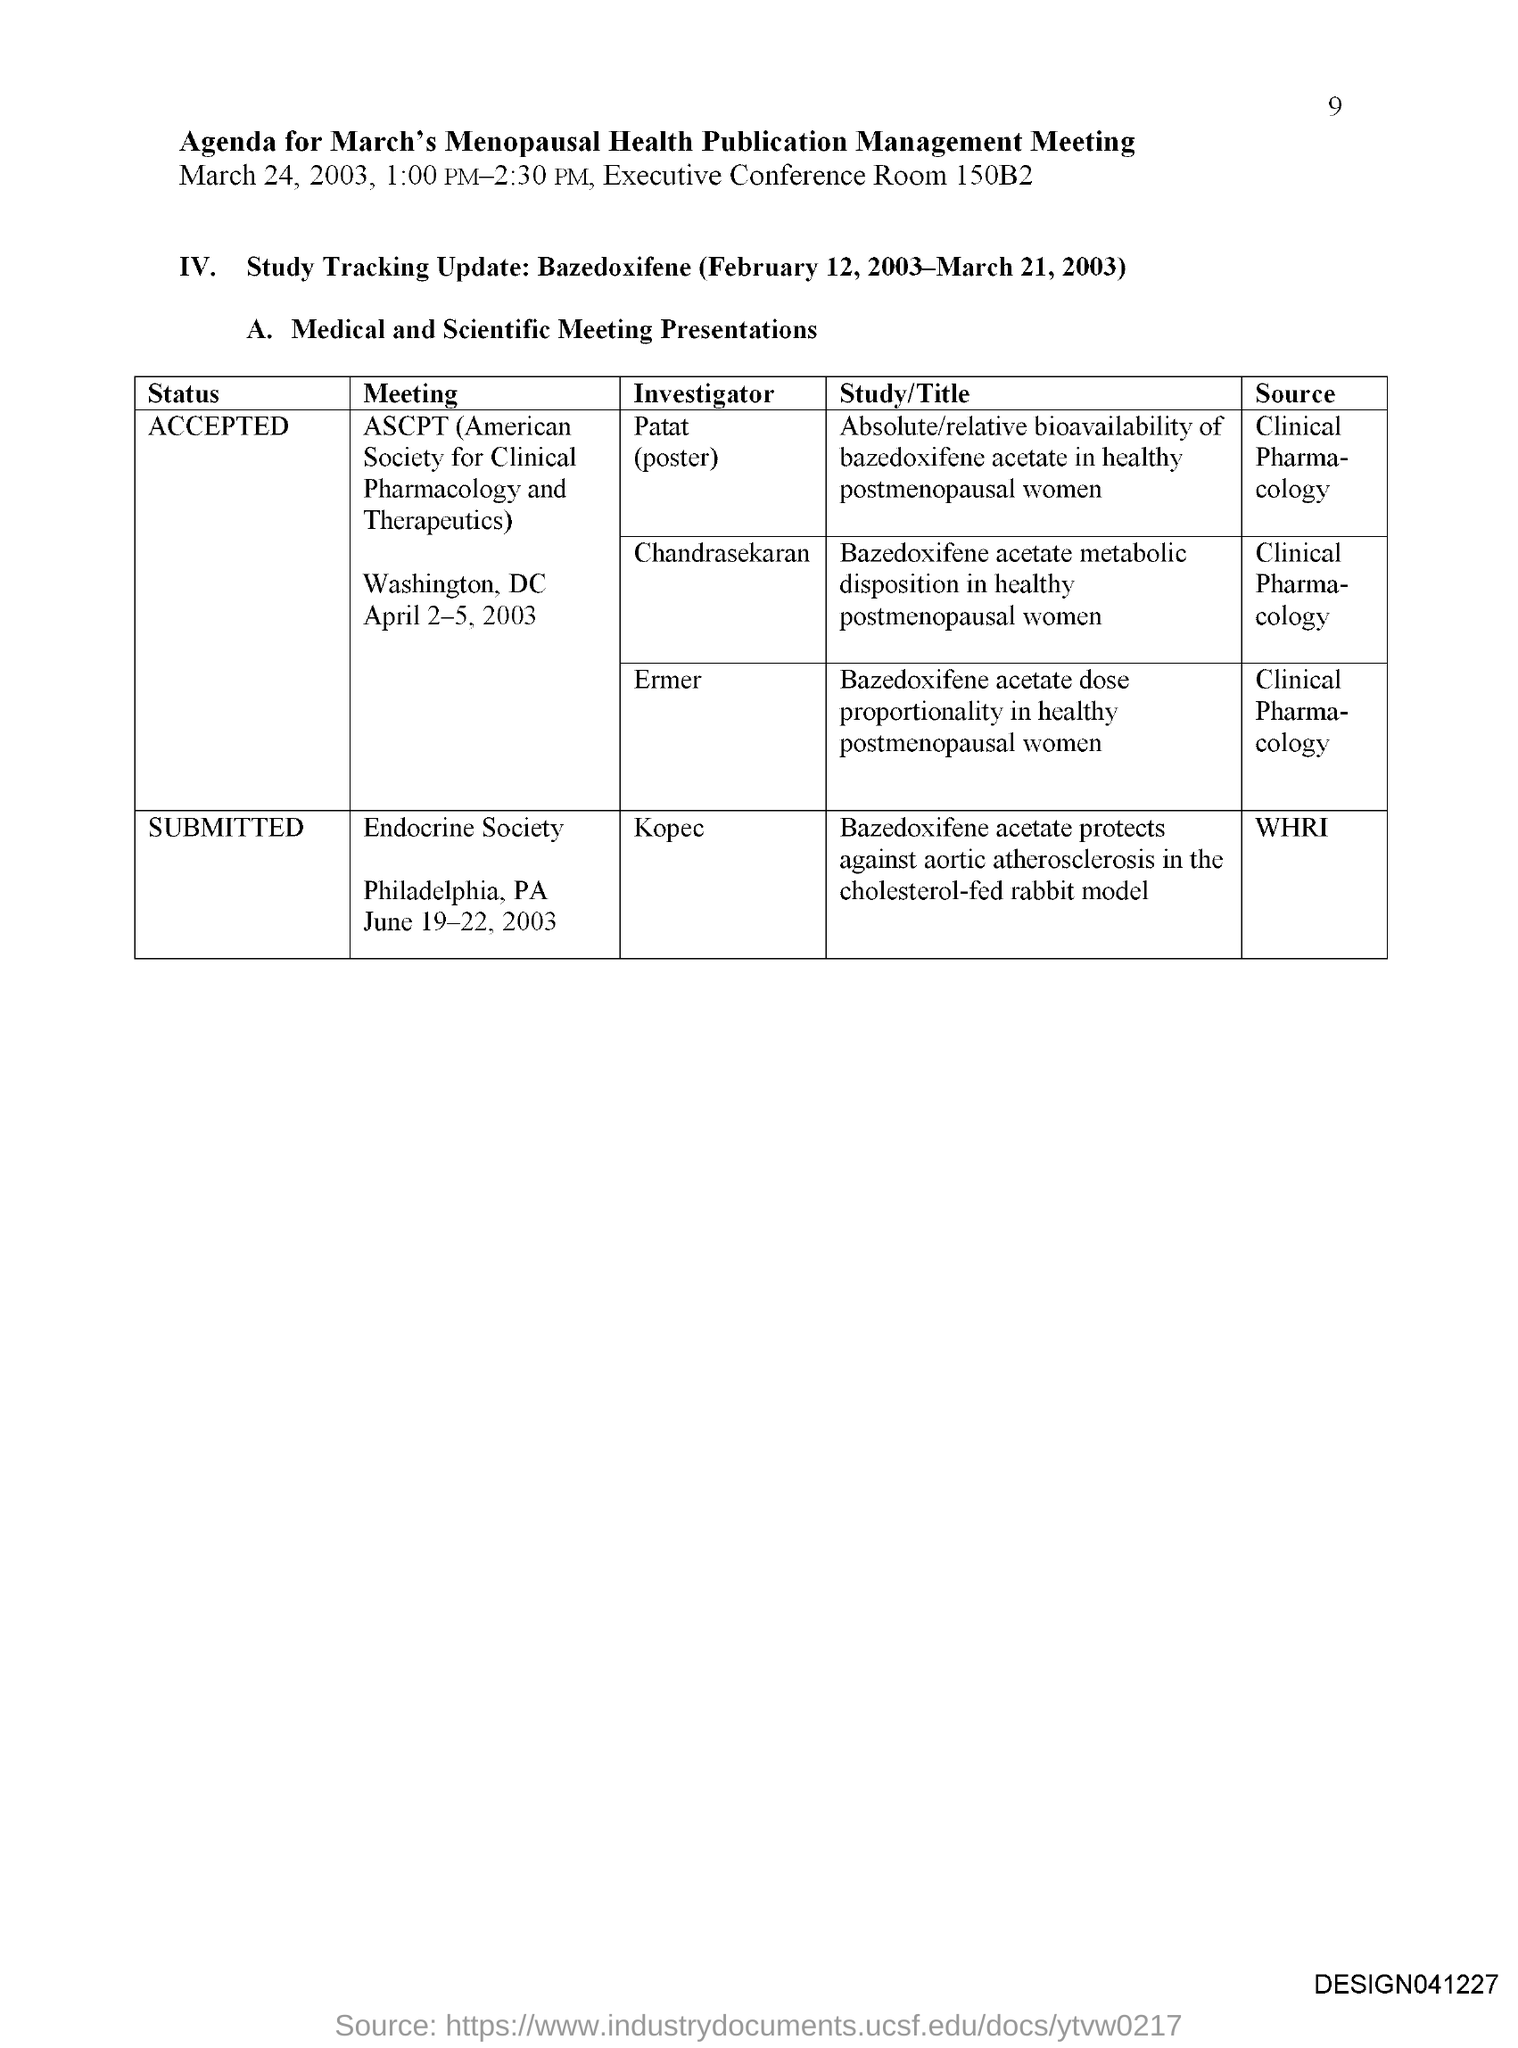What is the page number?
Your answer should be very brief. 9. What is the title of the document?
Make the answer very short. Agenda for March's Menopausal health publication management meeting. What is the conference room number?
Offer a terse response. 150B2. Who is the investigator of the meeting "Endocrine Society"?
Make the answer very short. Kopec. What is the status of the meeting "Endocrine Society"?
Your response must be concise. SUBMITTED. What is the full form of ASCPT?
Provide a short and direct response. American society for clinical pharmacology and therapeutics. What is the status of the meeting ASCPT?
Offer a terse response. Accepted. 